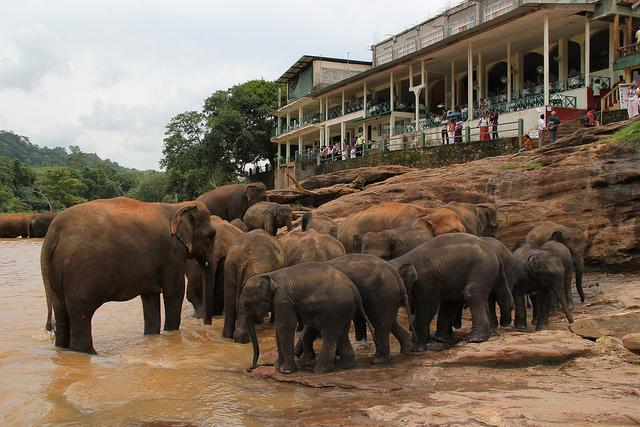What keeps the elephants out of the buildings?

Choices:
A) water
B) herders
C) noise
D) rocks rocks 